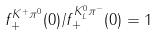Convert formula to latex. <formula><loc_0><loc_0><loc_500><loc_500>f _ { + } ^ { K ^ { + } \pi ^ { 0 } } ( 0 ) / f _ { + } ^ { K _ { L } ^ { 0 } \pi ^ { - } } ( 0 ) = 1</formula> 